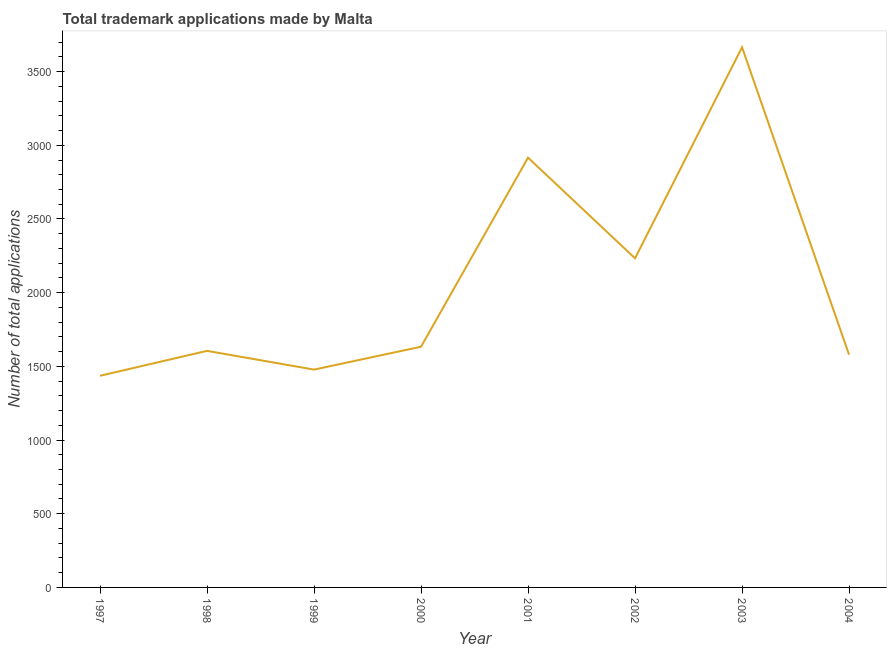What is the number of trademark applications in 1999?
Offer a terse response. 1478. Across all years, what is the maximum number of trademark applications?
Your response must be concise. 3665. Across all years, what is the minimum number of trademark applications?
Give a very brief answer. 1436. In which year was the number of trademark applications maximum?
Provide a short and direct response. 2003. In which year was the number of trademark applications minimum?
Your answer should be compact. 1997. What is the sum of the number of trademark applications?
Provide a short and direct response. 1.65e+04. What is the difference between the number of trademark applications in 2000 and 2003?
Ensure brevity in your answer.  -2032. What is the average number of trademark applications per year?
Provide a succinct answer. 2068.12. What is the median number of trademark applications?
Provide a short and direct response. 1619. In how many years, is the number of trademark applications greater than 3500 ?
Your answer should be compact. 1. Do a majority of the years between 2001 and 1997 (inclusive) have number of trademark applications greater than 2000 ?
Make the answer very short. Yes. What is the ratio of the number of trademark applications in 1999 to that in 2004?
Provide a succinct answer. 0.94. Is the difference between the number of trademark applications in 1997 and 2004 greater than the difference between any two years?
Ensure brevity in your answer.  No. What is the difference between the highest and the second highest number of trademark applications?
Give a very brief answer. 749. Is the sum of the number of trademark applications in 2003 and 2004 greater than the maximum number of trademark applications across all years?
Provide a short and direct response. Yes. What is the difference between the highest and the lowest number of trademark applications?
Your answer should be very brief. 2229. Does the number of trademark applications monotonically increase over the years?
Provide a short and direct response. No. What is the difference between two consecutive major ticks on the Y-axis?
Your response must be concise. 500. Are the values on the major ticks of Y-axis written in scientific E-notation?
Make the answer very short. No. Does the graph contain any zero values?
Keep it short and to the point. No. Does the graph contain grids?
Give a very brief answer. No. What is the title of the graph?
Offer a terse response. Total trademark applications made by Malta. What is the label or title of the Y-axis?
Offer a terse response. Number of total applications. What is the Number of total applications of 1997?
Offer a terse response. 1436. What is the Number of total applications of 1998?
Ensure brevity in your answer.  1605. What is the Number of total applications in 1999?
Provide a succinct answer. 1478. What is the Number of total applications in 2000?
Offer a terse response. 1633. What is the Number of total applications of 2001?
Your response must be concise. 2916. What is the Number of total applications in 2002?
Offer a terse response. 2233. What is the Number of total applications of 2003?
Offer a terse response. 3665. What is the Number of total applications of 2004?
Provide a short and direct response. 1579. What is the difference between the Number of total applications in 1997 and 1998?
Your answer should be very brief. -169. What is the difference between the Number of total applications in 1997 and 1999?
Offer a very short reply. -42. What is the difference between the Number of total applications in 1997 and 2000?
Give a very brief answer. -197. What is the difference between the Number of total applications in 1997 and 2001?
Make the answer very short. -1480. What is the difference between the Number of total applications in 1997 and 2002?
Provide a succinct answer. -797. What is the difference between the Number of total applications in 1997 and 2003?
Offer a very short reply. -2229. What is the difference between the Number of total applications in 1997 and 2004?
Provide a short and direct response. -143. What is the difference between the Number of total applications in 1998 and 1999?
Your response must be concise. 127. What is the difference between the Number of total applications in 1998 and 2000?
Your answer should be compact. -28. What is the difference between the Number of total applications in 1998 and 2001?
Provide a short and direct response. -1311. What is the difference between the Number of total applications in 1998 and 2002?
Ensure brevity in your answer.  -628. What is the difference between the Number of total applications in 1998 and 2003?
Keep it short and to the point. -2060. What is the difference between the Number of total applications in 1999 and 2000?
Ensure brevity in your answer.  -155. What is the difference between the Number of total applications in 1999 and 2001?
Offer a very short reply. -1438. What is the difference between the Number of total applications in 1999 and 2002?
Offer a very short reply. -755. What is the difference between the Number of total applications in 1999 and 2003?
Ensure brevity in your answer.  -2187. What is the difference between the Number of total applications in 1999 and 2004?
Your answer should be very brief. -101. What is the difference between the Number of total applications in 2000 and 2001?
Offer a very short reply. -1283. What is the difference between the Number of total applications in 2000 and 2002?
Your answer should be compact. -600. What is the difference between the Number of total applications in 2000 and 2003?
Make the answer very short. -2032. What is the difference between the Number of total applications in 2000 and 2004?
Keep it short and to the point. 54. What is the difference between the Number of total applications in 2001 and 2002?
Make the answer very short. 683. What is the difference between the Number of total applications in 2001 and 2003?
Your response must be concise. -749. What is the difference between the Number of total applications in 2001 and 2004?
Provide a short and direct response. 1337. What is the difference between the Number of total applications in 2002 and 2003?
Provide a short and direct response. -1432. What is the difference between the Number of total applications in 2002 and 2004?
Provide a short and direct response. 654. What is the difference between the Number of total applications in 2003 and 2004?
Make the answer very short. 2086. What is the ratio of the Number of total applications in 1997 to that in 1998?
Your response must be concise. 0.9. What is the ratio of the Number of total applications in 1997 to that in 2000?
Keep it short and to the point. 0.88. What is the ratio of the Number of total applications in 1997 to that in 2001?
Ensure brevity in your answer.  0.49. What is the ratio of the Number of total applications in 1997 to that in 2002?
Keep it short and to the point. 0.64. What is the ratio of the Number of total applications in 1997 to that in 2003?
Keep it short and to the point. 0.39. What is the ratio of the Number of total applications in 1997 to that in 2004?
Offer a very short reply. 0.91. What is the ratio of the Number of total applications in 1998 to that in 1999?
Ensure brevity in your answer.  1.09. What is the ratio of the Number of total applications in 1998 to that in 2001?
Give a very brief answer. 0.55. What is the ratio of the Number of total applications in 1998 to that in 2002?
Your answer should be very brief. 0.72. What is the ratio of the Number of total applications in 1998 to that in 2003?
Make the answer very short. 0.44. What is the ratio of the Number of total applications in 1998 to that in 2004?
Make the answer very short. 1.02. What is the ratio of the Number of total applications in 1999 to that in 2000?
Offer a terse response. 0.91. What is the ratio of the Number of total applications in 1999 to that in 2001?
Provide a short and direct response. 0.51. What is the ratio of the Number of total applications in 1999 to that in 2002?
Make the answer very short. 0.66. What is the ratio of the Number of total applications in 1999 to that in 2003?
Keep it short and to the point. 0.4. What is the ratio of the Number of total applications in 1999 to that in 2004?
Give a very brief answer. 0.94. What is the ratio of the Number of total applications in 2000 to that in 2001?
Provide a short and direct response. 0.56. What is the ratio of the Number of total applications in 2000 to that in 2002?
Your response must be concise. 0.73. What is the ratio of the Number of total applications in 2000 to that in 2003?
Your response must be concise. 0.45. What is the ratio of the Number of total applications in 2000 to that in 2004?
Offer a very short reply. 1.03. What is the ratio of the Number of total applications in 2001 to that in 2002?
Offer a terse response. 1.31. What is the ratio of the Number of total applications in 2001 to that in 2003?
Your answer should be very brief. 0.8. What is the ratio of the Number of total applications in 2001 to that in 2004?
Provide a short and direct response. 1.85. What is the ratio of the Number of total applications in 2002 to that in 2003?
Your response must be concise. 0.61. What is the ratio of the Number of total applications in 2002 to that in 2004?
Offer a terse response. 1.41. What is the ratio of the Number of total applications in 2003 to that in 2004?
Your response must be concise. 2.32. 